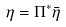<formula> <loc_0><loc_0><loc_500><loc_500>\eta = \Pi ^ { * } \bar { \eta }</formula> 